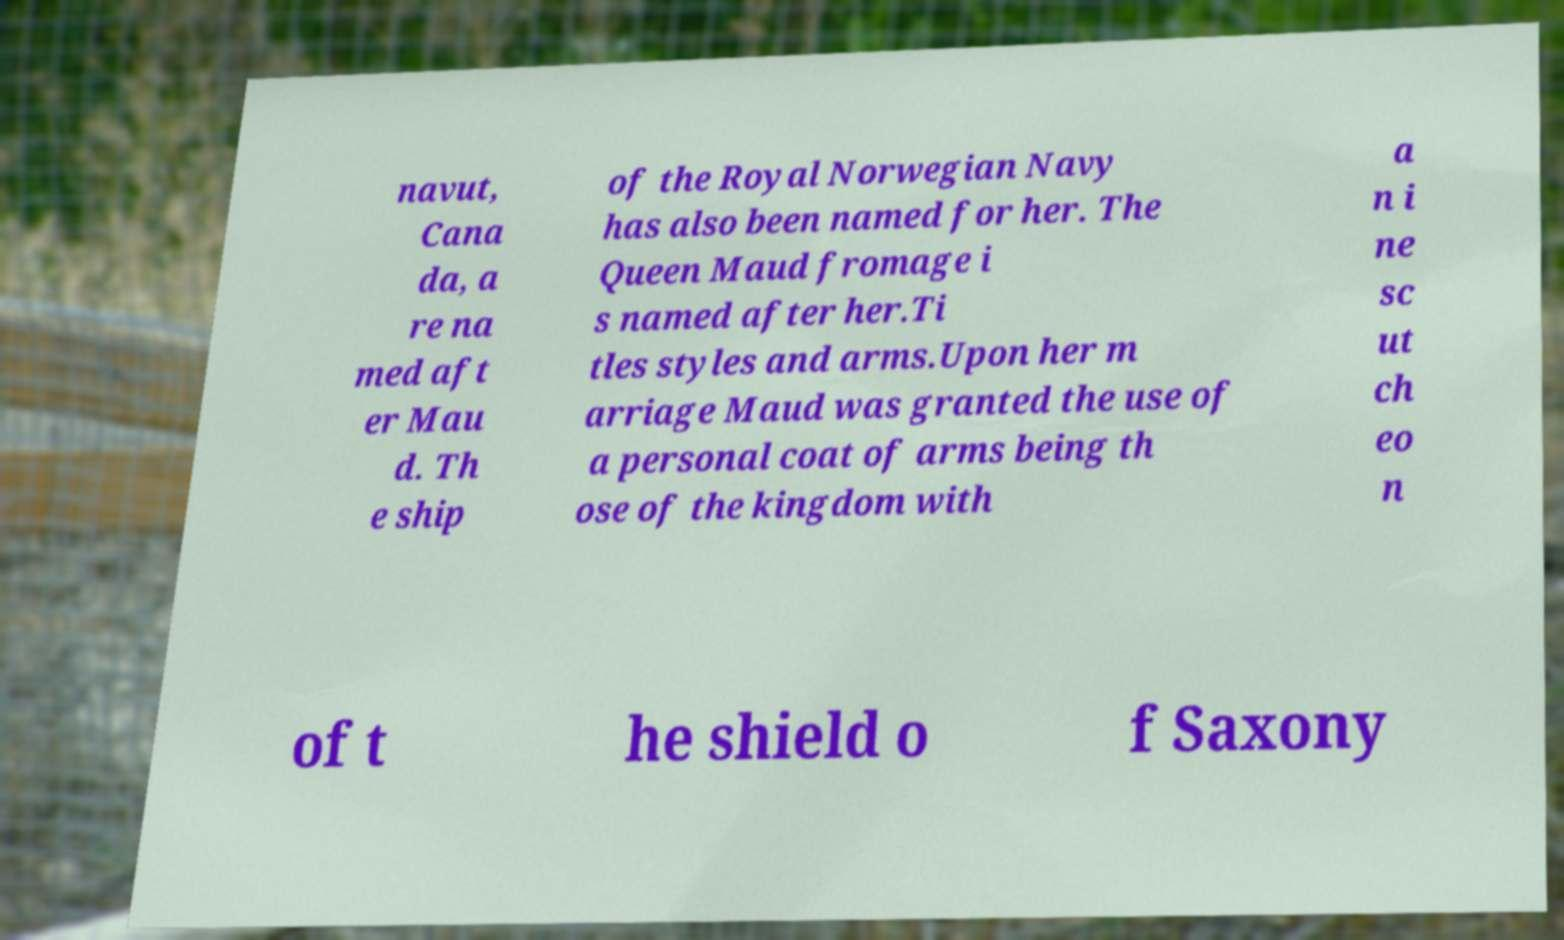Can you accurately transcribe the text from the provided image for me? navut, Cana da, a re na med aft er Mau d. Th e ship of the Royal Norwegian Navy has also been named for her. The Queen Maud fromage i s named after her.Ti tles styles and arms.Upon her m arriage Maud was granted the use of a personal coat of arms being th ose of the kingdom with a n i ne sc ut ch eo n of t he shield o f Saxony 